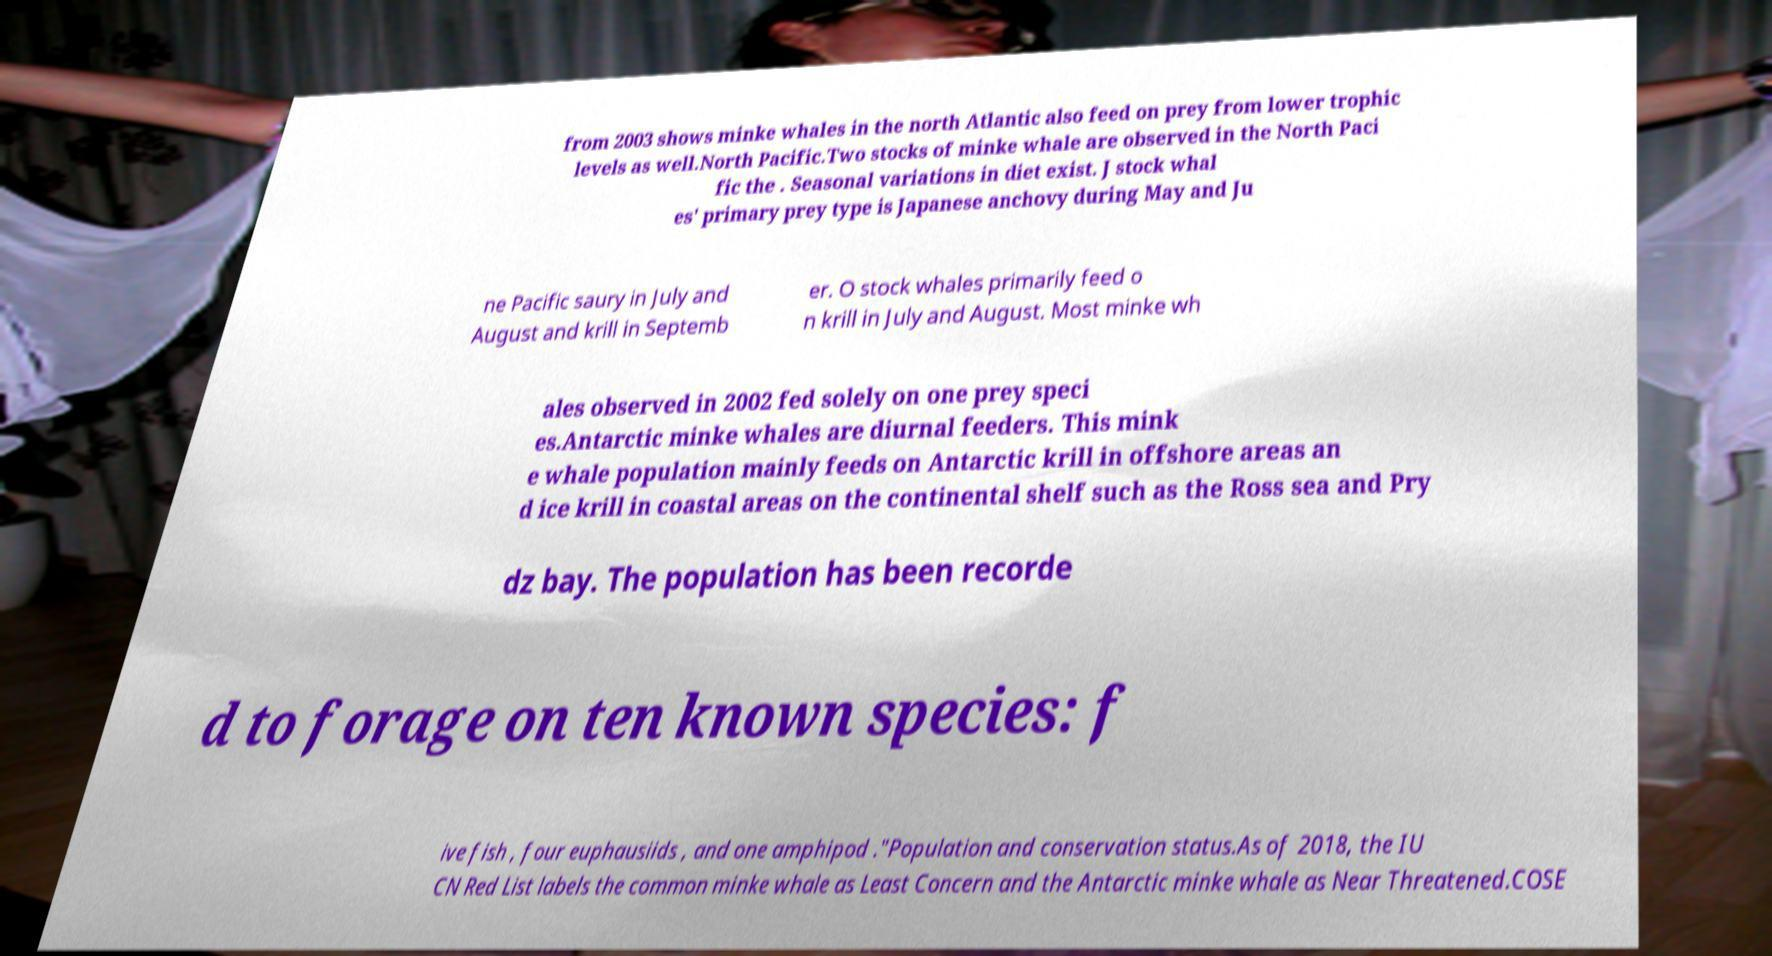Please read and relay the text visible in this image. What does it say? from 2003 shows minke whales in the north Atlantic also feed on prey from lower trophic levels as well.North Pacific.Two stocks of minke whale are observed in the North Paci fic the . Seasonal variations in diet exist. J stock whal es' primary prey type is Japanese anchovy during May and Ju ne Pacific saury in July and August and krill in Septemb er. O stock whales primarily feed o n krill in July and August. Most minke wh ales observed in 2002 fed solely on one prey speci es.Antarctic minke whales are diurnal feeders. This mink e whale population mainly feeds on Antarctic krill in offshore areas an d ice krill in coastal areas on the continental shelf such as the Ross sea and Pry dz bay. The population has been recorde d to forage on ten known species: f ive fish , four euphausiids , and one amphipod ."Population and conservation status.As of 2018, the IU CN Red List labels the common minke whale as Least Concern and the Antarctic minke whale as Near Threatened.COSE 